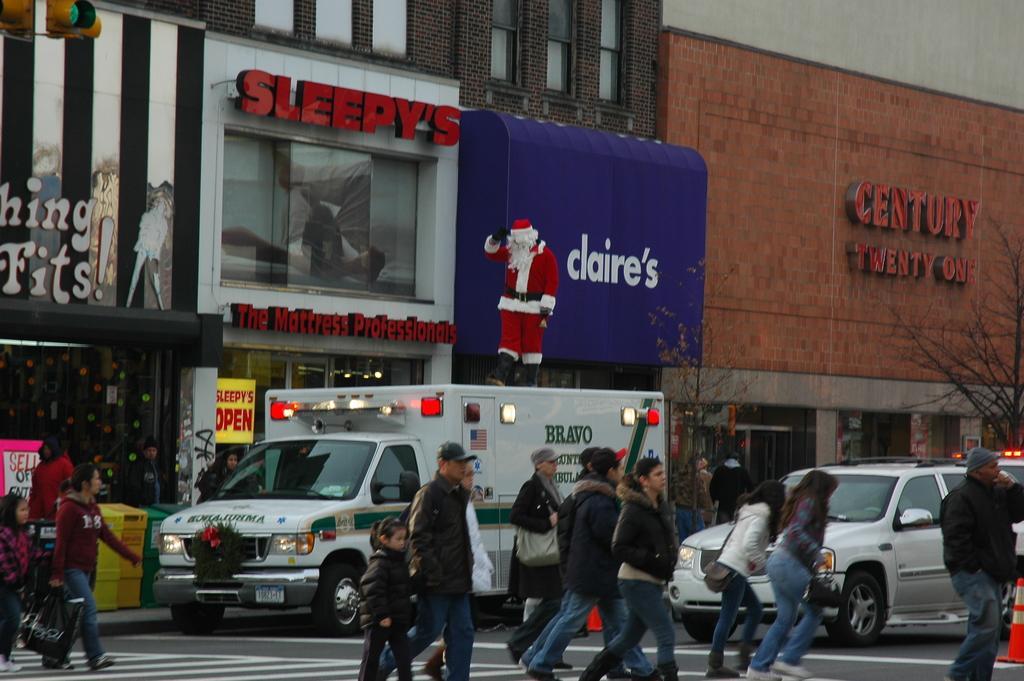How would you summarize this image in a sentence or two? In this picture there are some people crossing the road on a zebra crossing and there are some vehicle stopped on the road. In the background there is a shopping mall here and a wall. 